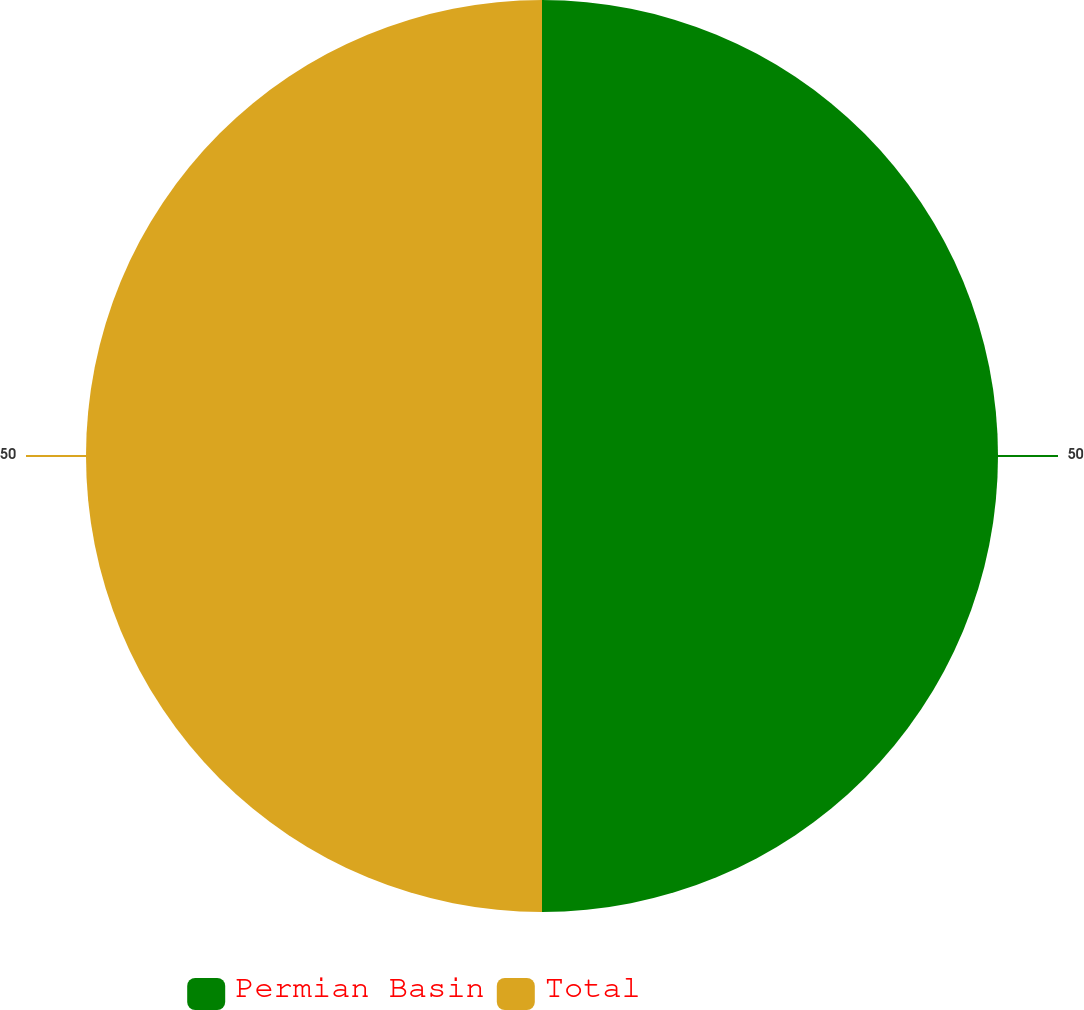Convert chart. <chart><loc_0><loc_0><loc_500><loc_500><pie_chart><fcel>Permian Basin<fcel>Total<nl><fcel>50.0%<fcel>50.0%<nl></chart> 